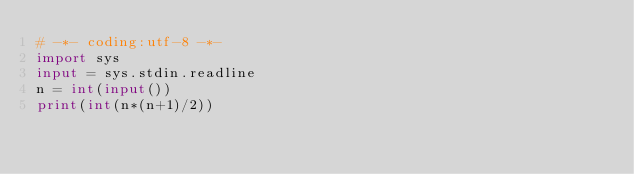<code> <loc_0><loc_0><loc_500><loc_500><_Python_># -*- coding:utf-8 -*-
import sys
input = sys.stdin.readline
n = int(input())
print(int(n*(n+1)/2))</code> 